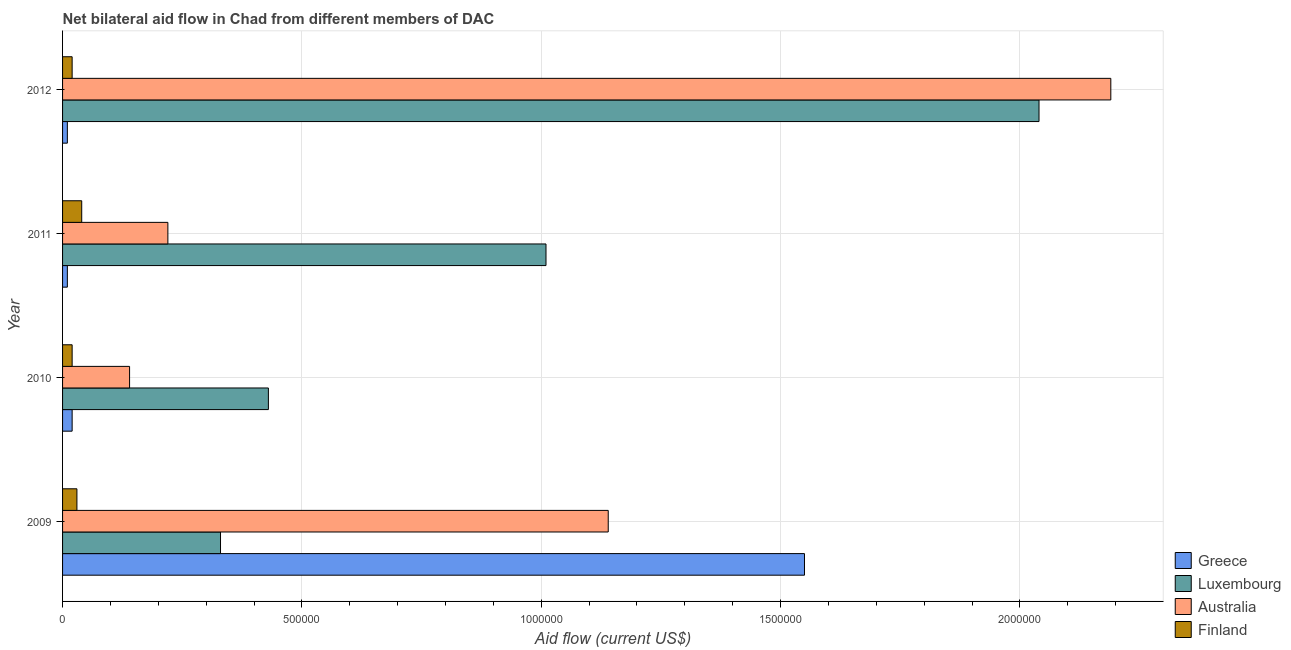How many groups of bars are there?
Offer a very short reply. 4. Are the number of bars per tick equal to the number of legend labels?
Offer a terse response. Yes. How many bars are there on the 1st tick from the top?
Ensure brevity in your answer.  4. In how many cases, is the number of bars for a given year not equal to the number of legend labels?
Your answer should be compact. 0. What is the amount of aid given by luxembourg in 2010?
Your answer should be very brief. 4.30e+05. Across all years, what is the maximum amount of aid given by australia?
Your response must be concise. 2.19e+06. Across all years, what is the minimum amount of aid given by greece?
Ensure brevity in your answer.  10000. In which year was the amount of aid given by greece minimum?
Give a very brief answer. 2011. What is the total amount of aid given by australia in the graph?
Provide a succinct answer. 3.69e+06. What is the difference between the amount of aid given by luxembourg in 2009 and that in 2011?
Your answer should be very brief. -6.80e+05. What is the difference between the amount of aid given by greece in 2012 and the amount of aid given by luxembourg in 2010?
Offer a very short reply. -4.20e+05. What is the average amount of aid given by greece per year?
Offer a terse response. 3.98e+05. In the year 2009, what is the difference between the amount of aid given by australia and amount of aid given by greece?
Offer a very short reply. -4.10e+05. Is the amount of aid given by australia in 2010 less than that in 2011?
Your answer should be very brief. Yes. What is the difference between the highest and the second highest amount of aid given by greece?
Your response must be concise. 1.53e+06. What is the difference between the highest and the lowest amount of aid given by greece?
Give a very brief answer. 1.54e+06. Is the sum of the amount of aid given by greece in 2009 and 2011 greater than the maximum amount of aid given by luxembourg across all years?
Make the answer very short. No. Is it the case that in every year, the sum of the amount of aid given by greece and amount of aid given by finland is greater than the sum of amount of aid given by luxembourg and amount of aid given by australia?
Keep it short and to the point. No. What does the 2nd bar from the top in 2012 represents?
Your response must be concise. Australia. What does the 2nd bar from the bottom in 2010 represents?
Ensure brevity in your answer.  Luxembourg. Is it the case that in every year, the sum of the amount of aid given by greece and amount of aid given by luxembourg is greater than the amount of aid given by australia?
Your response must be concise. No. Are all the bars in the graph horizontal?
Your answer should be very brief. Yes. How many years are there in the graph?
Provide a succinct answer. 4. Are the values on the major ticks of X-axis written in scientific E-notation?
Make the answer very short. No. Does the graph contain any zero values?
Give a very brief answer. No. What is the title of the graph?
Ensure brevity in your answer.  Net bilateral aid flow in Chad from different members of DAC. Does "Subsidies and Transfers" appear as one of the legend labels in the graph?
Provide a succinct answer. No. What is the label or title of the X-axis?
Ensure brevity in your answer.  Aid flow (current US$). What is the Aid flow (current US$) of Greece in 2009?
Ensure brevity in your answer.  1.55e+06. What is the Aid flow (current US$) of Luxembourg in 2009?
Ensure brevity in your answer.  3.30e+05. What is the Aid flow (current US$) of Australia in 2009?
Give a very brief answer. 1.14e+06. What is the Aid flow (current US$) of Finland in 2010?
Your answer should be compact. 2.00e+04. What is the Aid flow (current US$) of Luxembourg in 2011?
Offer a terse response. 1.01e+06. What is the Aid flow (current US$) in Greece in 2012?
Provide a short and direct response. 10000. What is the Aid flow (current US$) of Luxembourg in 2012?
Provide a succinct answer. 2.04e+06. What is the Aid flow (current US$) of Australia in 2012?
Your answer should be very brief. 2.19e+06. Across all years, what is the maximum Aid flow (current US$) in Greece?
Make the answer very short. 1.55e+06. Across all years, what is the maximum Aid flow (current US$) in Luxembourg?
Ensure brevity in your answer.  2.04e+06. Across all years, what is the maximum Aid flow (current US$) of Australia?
Keep it short and to the point. 2.19e+06. Across all years, what is the minimum Aid flow (current US$) in Australia?
Give a very brief answer. 1.40e+05. What is the total Aid flow (current US$) of Greece in the graph?
Offer a terse response. 1.59e+06. What is the total Aid flow (current US$) in Luxembourg in the graph?
Give a very brief answer. 3.81e+06. What is the total Aid flow (current US$) of Australia in the graph?
Give a very brief answer. 3.69e+06. What is the difference between the Aid flow (current US$) in Greece in 2009 and that in 2010?
Make the answer very short. 1.53e+06. What is the difference between the Aid flow (current US$) of Luxembourg in 2009 and that in 2010?
Your answer should be very brief. -1.00e+05. What is the difference between the Aid flow (current US$) in Australia in 2009 and that in 2010?
Provide a succinct answer. 1.00e+06. What is the difference between the Aid flow (current US$) of Finland in 2009 and that in 2010?
Offer a terse response. 10000. What is the difference between the Aid flow (current US$) of Greece in 2009 and that in 2011?
Provide a succinct answer. 1.54e+06. What is the difference between the Aid flow (current US$) of Luxembourg in 2009 and that in 2011?
Offer a very short reply. -6.80e+05. What is the difference between the Aid flow (current US$) in Australia in 2009 and that in 2011?
Offer a terse response. 9.20e+05. What is the difference between the Aid flow (current US$) in Greece in 2009 and that in 2012?
Provide a short and direct response. 1.54e+06. What is the difference between the Aid flow (current US$) in Luxembourg in 2009 and that in 2012?
Give a very brief answer. -1.71e+06. What is the difference between the Aid flow (current US$) of Australia in 2009 and that in 2012?
Offer a very short reply. -1.05e+06. What is the difference between the Aid flow (current US$) in Greece in 2010 and that in 2011?
Give a very brief answer. 10000. What is the difference between the Aid flow (current US$) of Luxembourg in 2010 and that in 2011?
Offer a very short reply. -5.80e+05. What is the difference between the Aid flow (current US$) of Australia in 2010 and that in 2011?
Offer a terse response. -8.00e+04. What is the difference between the Aid flow (current US$) in Luxembourg in 2010 and that in 2012?
Provide a short and direct response. -1.61e+06. What is the difference between the Aid flow (current US$) in Australia in 2010 and that in 2012?
Provide a succinct answer. -2.05e+06. What is the difference between the Aid flow (current US$) in Greece in 2011 and that in 2012?
Offer a very short reply. 0. What is the difference between the Aid flow (current US$) in Luxembourg in 2011 and that in 2012?
Keep it short and to the point. -1.03e+06. What is the difference between the Aid flow (current US$) in Australia in 2011 and that in 2012?
Your answer should be compact. -1.97e+06. What is the difference between the Aid flow (current US$) in Finland in 2011 and that in 2012?
Your answer should be compact. 2.00e+04. What is the difference between the Aid flow (current US$) in Greece in 2009 and the Aid flow (current US$) in Luxembourg in 2010?
Your answer should be compact. 1.12e+06. What is the difference between the Aid flow (current US$) in Greece in 2009 and the Aid flow (current US$) in Australia in 2010?
Offer a terse response. 1.41e+06. What is the difference between the Aid flow (current US$) in Greece in 2009 and the Aid flow (current US$) in Finland in 2010?
Your answer should be very brief. 1.53e+06. What is the difference between the Aid flow (current US$) in Luxembourg in 2009 and the Aid flow (current US$) in Australia in 2010?
Provide a succinct answer. 1.90e+05. What is the difference between the Aid flow (current US$) in Luxembourg in 2009 and the Aid flow (current US$) in Finland in 2010?
Keep it short and to the point. 3.10e+05. What is the difference between the Aid flow (current US$) in Australia in 2009 and the Aid flow (current US$) in Finland in 2010?
Your answer should be very brief. 1.12e+06. What is the difference between the Aid flow (current US$) of Greece in 2009 and the Aid flow (current US$) of Luxembourg in 2011?
Ensure brevity in your answer.  5.40e+05. What is the difference between the Aid flow (current US$) of Greece in 2009 and the Aid flow (current US$) of Australia in 2011?
Make the answer very short. 1.33e+06. What is the difference between the Aid flow (current US$) of Greece in 2009 and the Aid flow (current US$) of Finland in 2011?
Provide a succinct answer. 1.51e+06. What is the difference between the Aid flow (current US$) of Luxembourg in 2009 and the Aid flow (current US$) of Australia in 2011?
Offer a terse response. 1.10e+05. What is the difference between the Aid flow (current US$) of Australia in 2009 and the Aid flow (current US$) of Finland in 2011?
Ensure brevity in your answer.  1.10e+06. What is the difference between the Aid flow (current US$) of Greece in 2009 and the Aid flow (current US$) of Luxembourg in 2012?
Provide a succinct answer. -4.90e+05. What is the difference between the Aid flow (current US$) of Greece in 2009 and the Aid flow (current US$) of Australia in 2012?
Your response must be concise. -6.40e+05. What is the difference between the Aid flow (current US$) in Greece in 2009 and the Aid flow (current US$) in Finland in 2012?
Your response must be concise. 1.53e+06. What is the difference between the Aid flow (current US$) in Luxembourg in 2009 and the Aid flow (current US$) in Australia in 2012?
Make the answer very short. -1.86e+06. What is the difference between the Aid flow (current US$) of Luxembourg in 2009 and the Aid flow (current US$) of Finland in 2012?
Provide a succinct answer. 3.10e+05. What is the difference between the Aid flow (current US$) of Australia in 2009 and the Aid flow (current US$) of Finland in 2012?
Ensure brevity in your answer.  1.12e+06. What is the difference between the Aid flow (current US$) in Greece in 2010 and the Aid flow (current US$) in Luxembourg in 2011?
Give a very brief answer. -9.90e+05. What is the difference between the Aid flow (current US$) in Luxembourg in 2010 and the Aid flow (current US$) in Finland in 2011?
Keep it short and to the point. 3.90e+05. What is the difference between the Aid flow (current US$) in Greece in 2010 and the Aid flow (current US$) in Luxembourg in 2012?
Offer a very short reply. -2.02e+06. What is the difference between the Aid flow (current US$) of Greece in 2010 and the Aid flow (current US$) of Australia in 2012?
Your answer should be very brief. -2.17e+06. What is the difference between the Aid flow (current US$) in Luxembourg in 2010 and the Aid flow (current US$) in Australia in 2012?
Provide a short and direct response. -1.76e+06. What is the difference between the Aid flow (current US$) in Greece in 2011 and the Aid flow (current US$) in Luxembourg in 2012?
Keep it short and to the point. -2.03e+06. What is the difference between the Aid flow (current US$) of Greece in 2011 and the Aid flow (current US$) of Australia in 2012?
Offer a very short reply. -2.18e+06. What is the difference between the Aid flow (current US$) of Greece in 2011 and the Aid flow (current US$) of Finland in 2012?
Your answer should be compact. -10000. What is the difference between the Aid flow (current US$) in Luxembourg in 2011 and the Aid flow (current US$) in Australia in 2012?
Offer a very short reply. -1.18e+06. What is the difference between the Aid flow (current US$) in Luxembourg in 2011 and the Aid flow (current US$) in Finland in 2012?
Offer a very short reply. 9.90e+05. What is the difference between the Aid flow (current US$) of Australia in 2011 and the Aid flow (current US$) of Finland in 2012?
Make the answer very short. 2.00e+05. What is the average Aid flow (current US$) in Greece per year?
Your response must be concise. 3.98e+05. What is the average Aid flow (current US$) of Luxembourg per year?
Offer a very short reply. 9.52e+05. What is the average Aid flow (current US$) of Australia per year?
Your answer should be compact. 9.22e+05. What is the average Aid flow (current US$) of Finland per year?
Your response must be concise. 2.75e+04. In the year 2009, what is the difference between the Aid flow (current US$) in Greece and Aid flow (current US$) in Luxembourg?
Provide a succinct answer. 1.22e+06. In the year 2009, what is the difference between the Aid flow (current US$) of Greece and Aid flow (current US$) of Finland?
Provide a succinct answer. 1.52e+06. In the year 2009, what is the difference between the Aid flow (current US$) in Luxembourg and Aid flow (current US$) in Australia?
Your answer should be very brief. -8.10e+05. In the year 2009, what is the difference between the Aid flow (current US$) of Australia and Aid flow (current US$) of Finland?
Offer a very short reply. 1.11e+06. In the year 2010, what is the difference between the Aid flow (current US$) of Greece and Aid flow (current US$) of Luxembourg?
Provide a short and direct response. -4.10e+05. In the year 2010, what is the difference between the Aid flow (current US$) of Luxembourg and Aid flow (current US$) of Australia?
Provide a succinct answer. 2.90e+05. In the year 2011, what is the difference between the Aid flow (current US$) in Greece and Aid flow (current US$) in Australia?
Offer a very short reply. -2.10e+05. In the year 2011, what is the difference between the Aid flow (current US$) in Greece and Aid flow (current US$) in Finland?
Make the answer very short. -3.00e+04. In the year 2011, what is the difference between the Aid flow (current US$) of Luxembourg and Aid flow (current US$) of Australia?
Make the answer very short. 7.90e+05. In the year 2011, what is the difference between the Aid flow (current US$) in Luxembourg and Aid flow (current US$) in Finland?
Offer a very short reply. 9.70e+05. In the year 2012, what is the difference between the Aid flow (current US$) of Greece and Aid flow (current US$) of Luxembourg?
Your answer should be very brief. -2.03e+06. In the year 2012, what is the difference between the Aid flow (current US$) of Greece and Aid flow (current US$) of Australia?
Provide a short and direct response. -2.18e+06. In the year 2012, what is the difference between the Aid flow (current US$) in Greece and Aid flow (current US$) in Finland?
Your response must be concise. -10000. In the year 2012, what is the difference between the Aid flow (current US$) in Luxembourg and Aid flow (current US$) in Finland?
Provide a succinct answer. 2.02e+06. In the year 2012, what is the difference between the Aid flow (current US$) of Australia and Aid flow (current US$) of Finland?
Ensure brevity in your answer.  2.17e+06. What is the ratio of the Aid flow (current US$) of Greece in 2009 to that in 2010?
Your response must be concise. 77.5. What is the ratio of the Aid flow (current US$) of Luxembourg in 2009 to that in 2010?
Give a very brief answer. 0.77. What is the ratio of the Aid flow (current US$) of Australia in 2009 to that in 2010?
Give a very brief answer. 8.14. What is the ratio of the Aid flow (current US$) of Finland in 2009 to that in 2010?
Your response must be concise. 1.5. What is the ratio of the Aid flow (current US$) in Greece in 2009 to that in 2011?
Keep it short and to the point. 155. What is the ratio of the Aid flow (current US$) of Luxembourg in 2009 to that in 2011?
Your answer should be compact. 0.33. What is the ratio of the Aid flow (current US$) of Australia in 2009 to that in 2011?
Provide a short and direct response. 5.18. What is the ratio of the Aid flow (current US$) of Finland in 2009 to that in 2011?
Keep it short and to the point. 0.75. What is the ratio of the Aid flow (current US$) of Greece in 2009 to that in 2012?
Your answer should be compact. 155. What is the ratio of the Aid flow (current US$) of Luxembourg in 2009 to that in 2012?
Make the answer very short. 0.16. What is the ratio of the Aid flow (current US$) of Australia in 2009 to that in 2012?
Give a very brief answer. 0.52. What is the ratio of the Aid flow (current US$) in Finland in 2009 to that in 2012?
Your response must be concise. 1.5. What is the ratio of the Aid flow (current US$) in Luxembourg in 2010 to that in 2011?
Provide a short and direct response. 0.43. What is the ratio of the Aid flow (current US$) in Australia in 2010 to that in 2011?
Provide a succinct answer. 0.64. What is the ratio of the Aid flow (current US$) of Finland in 2010 to that in 2011?
Provide a short and direct response. 0.5. What is the ratio of the Aid flow (current US$) in Luxembourg in 2010 to that in 2012?
Offer a very short reply. 0.21. What is the ratio of the Aid flow (current US$) in Australia in 2010 to that in 2012?
Provide a short and direct response. 0.06. What is the ratio of the Aid flow (current US$) of Luxembourg in 2011 to that in 2012?
Offer a terse response. 0.5. What is the ratio of the Aid flow (current US$) in Australia in 2011 to that in 2012?
Your answer should be compact. 0.1. What is the ratio of the Aid flow (current US$) in Finland in 2011 to that in 2012?
Offer a terse response. 2. What is the difference between the highest and the second highest Aid flow (current US$) of Greece?
Keep it short and to the point. 1.53e+06. What is the difference between the highest and the second highest Aid flow (current US$) in Luxembourg?
Your answer should be very brief. 1.03e+06. What is the difference between the highest and the second highest Aid flow (current US$) of Australia?
Keep it short and to the point. 1.05e+06. What is the difference between the highest and the lowest Aid flow (current US$) in Greece?
Ensure brevity in your answer.  1.54e+06. What is the difference between the highest and the lowest Aid flow (current US$) in Luxembourg?
Offer a terse response. 1.71e+06. What is the difference between the highest and the lowest Aid flow (current US$) in Australia?
Your response must be concise. 2.05e+06. What is the difference between the highest and the lowest Aid flow (current US$) in Finland?
Ensure brevity in your answer.  2.00e+04. 